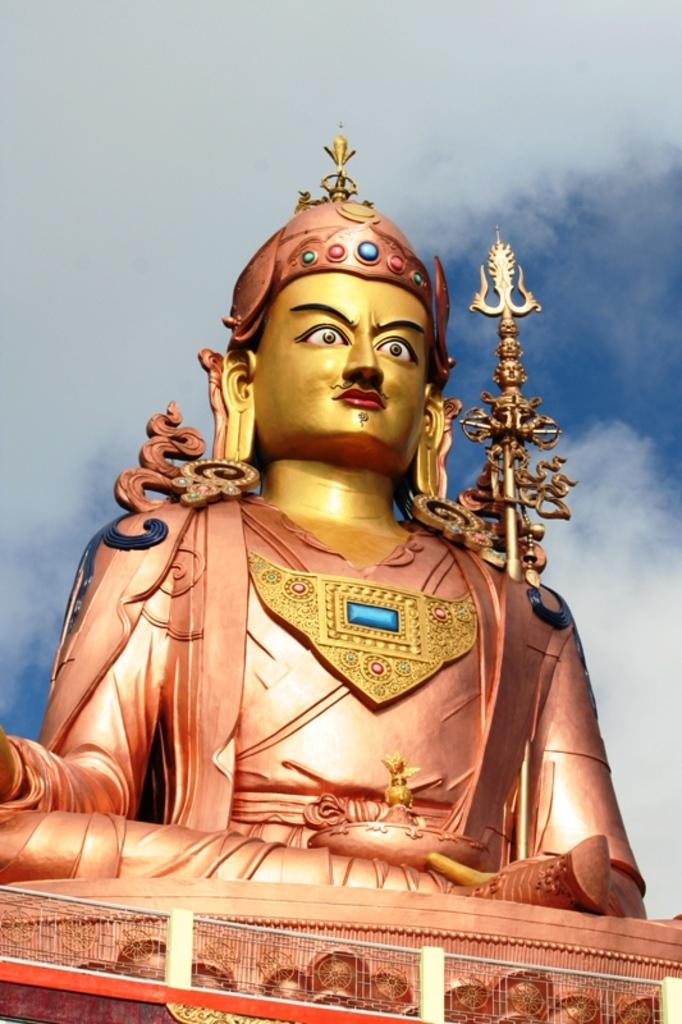What is the main subject of the image? There is a sculpture in the image. What is located at the bottom of the image? There is railing at the bottom of the image. How would you describe the sky in the image? The sky is cloudy in the image. What type of glue is being used to hold the cactus in the image? There is no glue or cactus present in the image; it features a sculpture and railing with a cloudy sky. 